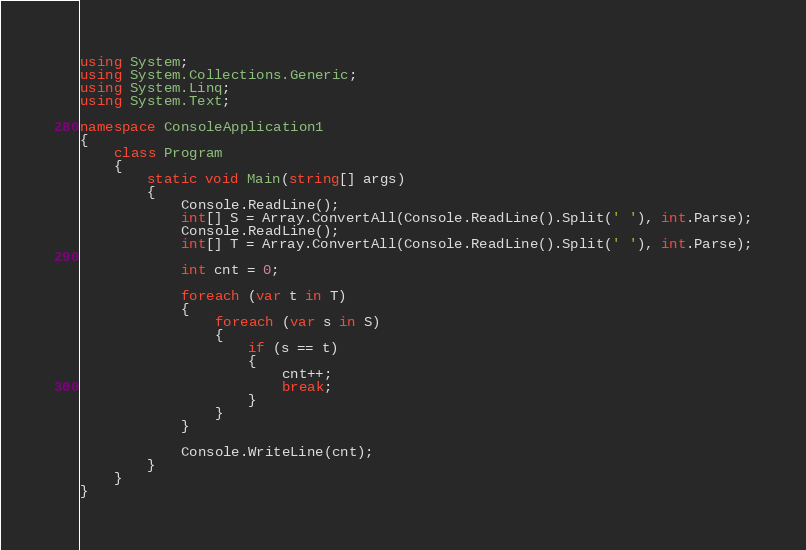<code> <loc_0><loc_0><loc_500><loc_500><_C#_>using System;
using System.Collections.Generic;
using System.Linq;
using System.Text;
 
namespace ConsoleApplication1
{
    class Program
    {
        static void Main(string[] args)
        {
            Console.ReadLine();
            int[] S = Array.ConvertAll(Console.ReadLine().Split(' '), int.Parse);
            Console.ReadLine();
            int[] T = Array.ConvertAll(Console.ReadLine().Split(' '), int.Parse);
 
            int cnt = 0;
 
            foreach (var t in T)
            {
                foreach (var s in S)
                {
                    if (s == t)
                    {
                        cnt++;
                        break;
                    }
                }
            }
 
            Console.WriteLine(cnt);
        }
    }
}</code> 